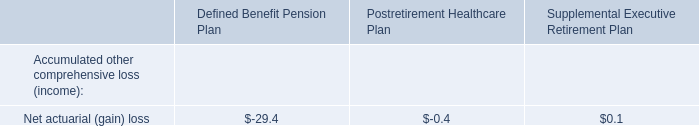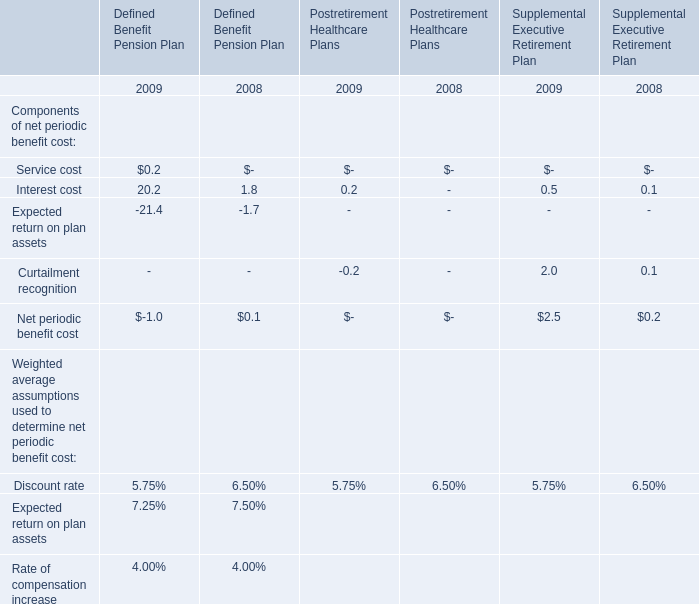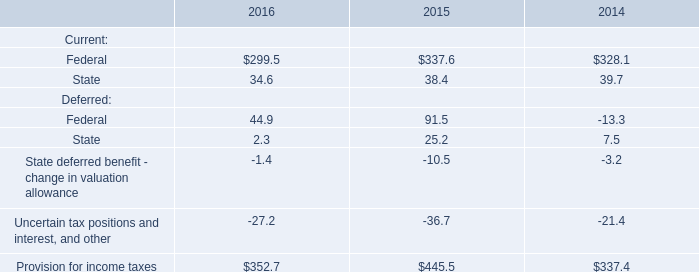As As the chart 1 shows,which year is Interest cost for Defined Benefit Pension Plan the most? 
Answer: 2009. 